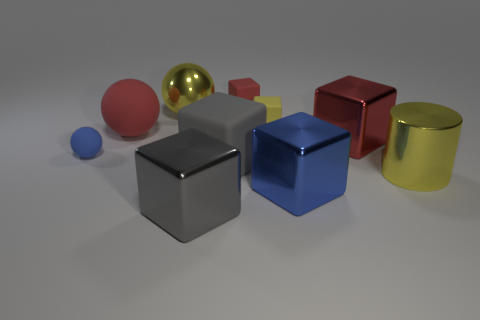How many tiny yellow objects are the same shape as the big red rubber object?
Provide a short and direct response. 0. What is the material of the small yellow cube?
Give a very brief answer. Rubber. There is a small matte ball; is it the same color as the ball behind the large red matte sphere?
Your response must be concise. No. What number of balls are either blue metallic things or big red matte objects?
Give a very brief answer. 1. There is a tiny rubber cube that is in front of the yellow ball; what is its color?
Your answer should be compact. Yellow. What shape is the rubber object that is the same color as the big cylinder?
Your answer should be compact. Cube. How many blue objects have the same size as the metallic cylinder?
Ensure brevity in your answer.  1. There is a large yellow object that is right of the yellow rubber object; is its shape the same as the red thing behind the large yellow shiny ball?
Offer a terse response. No. There is a large red object to the right of the yellow metallic thing behind the blue object behind the big yellow metal cylinder; what is it made of?
Your answer should be compact. Metal. The other matte thing that is the same size as the gray rubber thing is what shape?
Your answer should be compact. Sphere. 